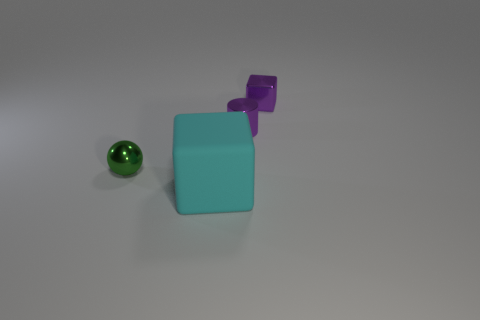Add 1 large cyan matte things. How many objects exist? 5 Subtract all purple blocks. How many blocks are left? 1 Subtract all cylinders. How many objects are left? 3 Subtract 1 blocks. How many blocks are left? 1 Subtract all red spheres. Subtract all purple blocks. How many spheres are left? 1 Subtract all gray balls. How many cyan blocks are left? 1 Subtract all tiny purple things. Subtract all tiny purple cylinders. How many objects are left? 1 Add 3 purple things. How many purple things are left? 5 Add 3 small purple metal cubes. How many small purple metal cubes exist? 4 Subtract 0 brown blocks. How many objects are left? 4 